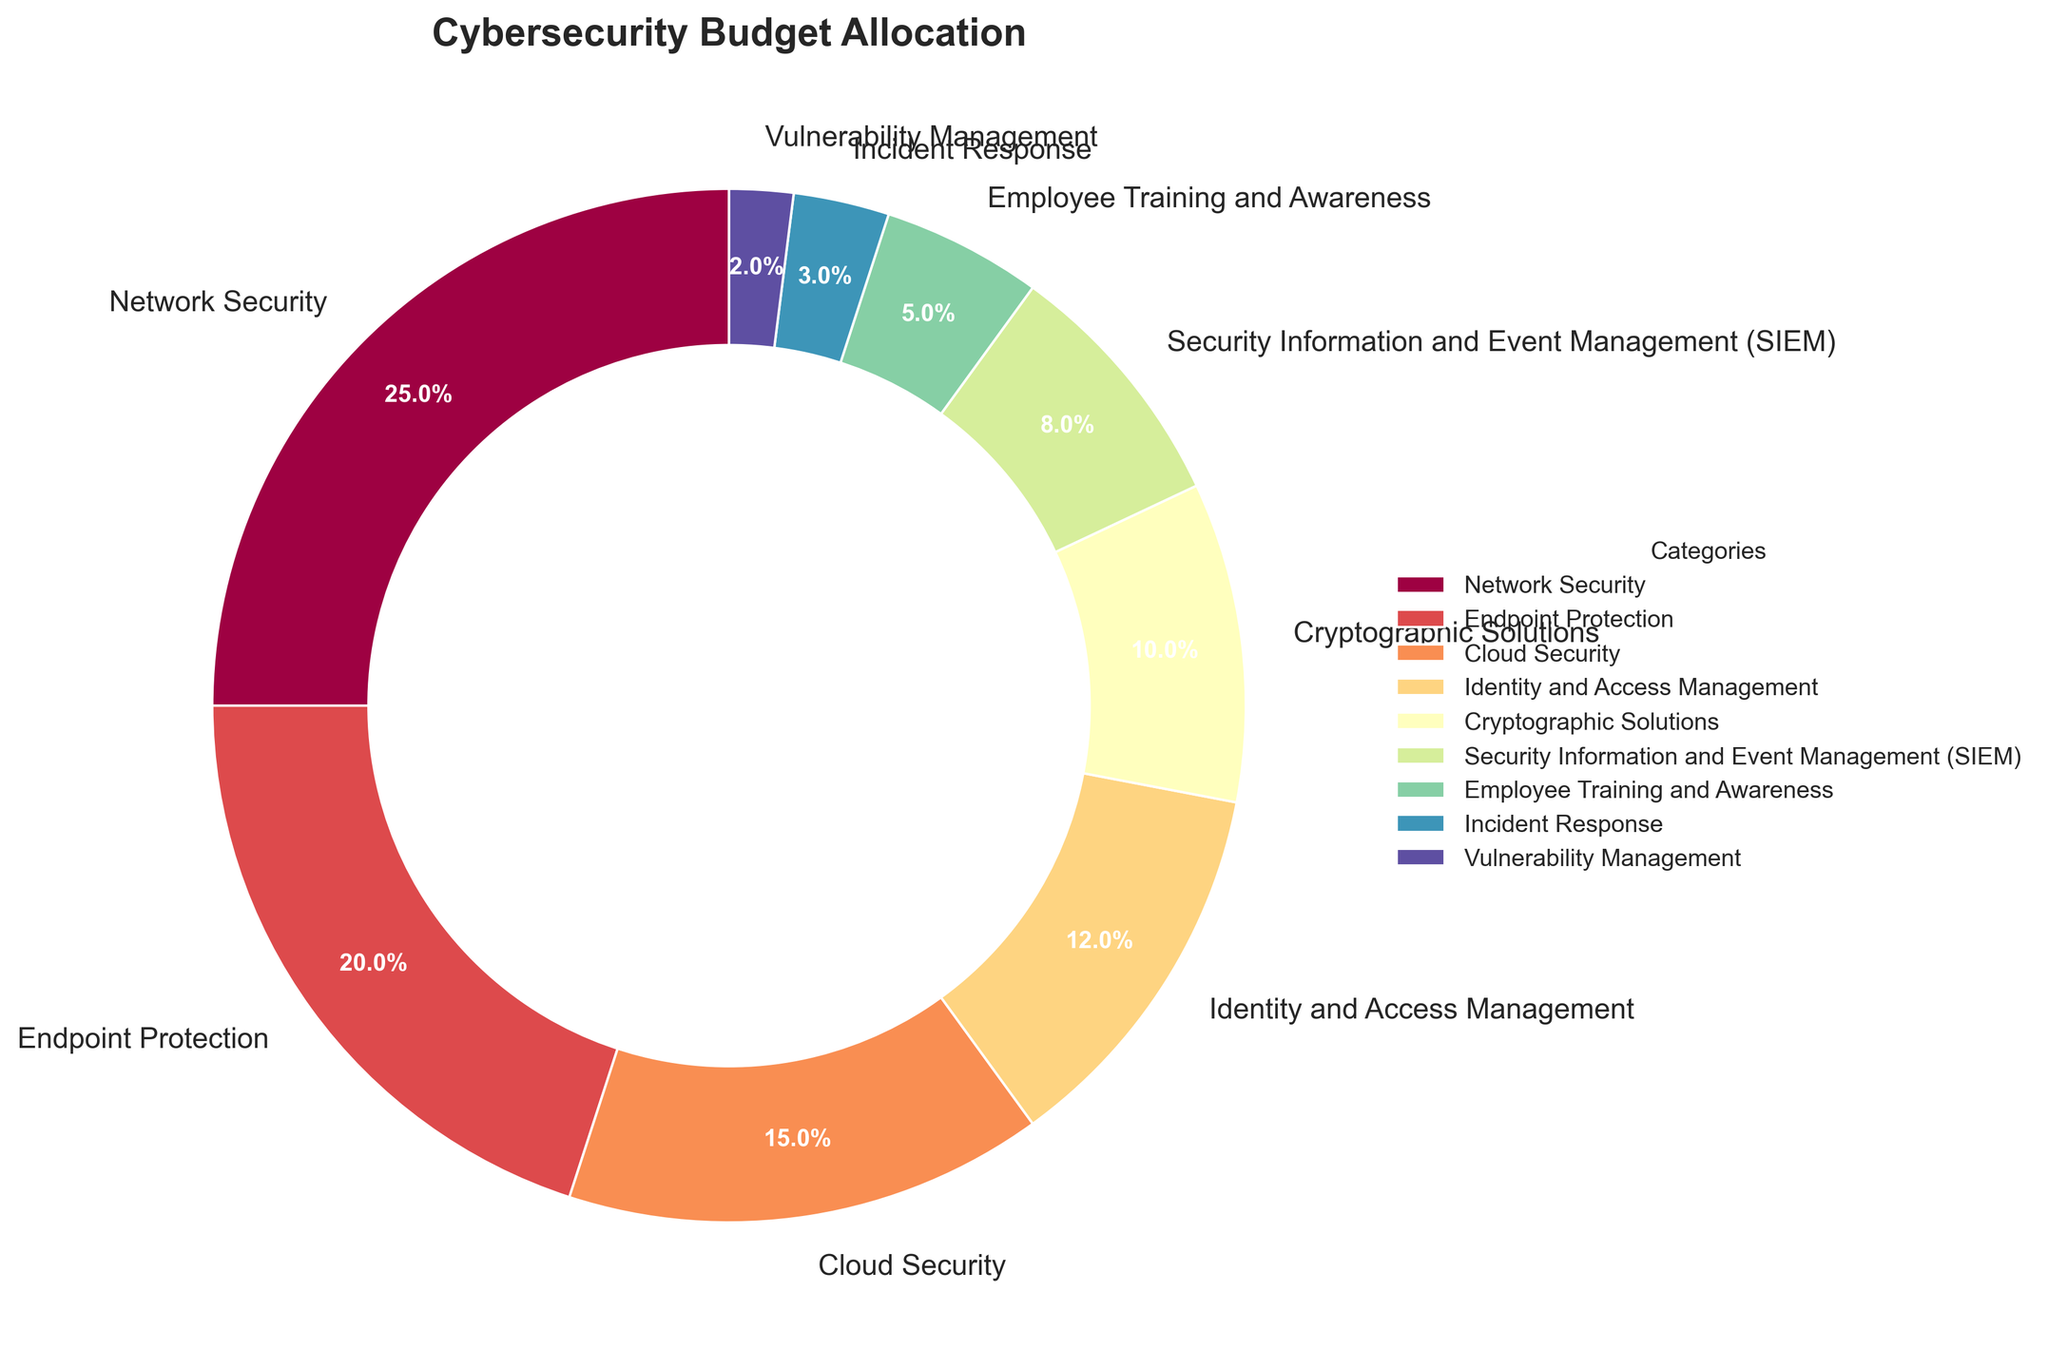What percentage of the budget is allocated to Cryptographic Solutions? Locate the section labeled "Cryptographic Solutions" in the pie chart. It shows 10%, meaning that 10% of the total cybersecurity budget is allocated to cryptographic solutions.
Answer: 10% Which category receives the highest percentage of the budget? Check the segment with the largest slice in the pie chart. Network Security shows the largest slice at 25%.
Answer: Network Security What is the total percentage allocated to Endpoint Protection and Cloud Security combined? Locate the percentages for Endpoint Protection (20%) and Cloud Security (15%). Add these values: 20% + 15% = 35%.
Answer: 35% Is more budget allocated to Identity and Access Management or Employee Training and Awareness? Compare the segments for Identity and Access Management (12%) and Employee Training and Awareness (5%). 12% is larger than 5%.
Answer: Identity and Access Management What is the difference between the budgets allocated to Network Security and Incident Response? Locate the percentages for Network Security (25%) and Incident Response (3%). Subtract the smaller percentage from the larger one: 25% - 3% = 22%.
Answer: 22% Which categories have a budget allocation equal to or less than 10%? Identify segments with 10% or lower. These are Cryptographic Solutions (10%), Security Information and Event Management (8%), Employee Training and Awareness (5%), Incident Response (3%), and Vulnerability Management (2%).
Answer: Cryptographic Solutions, SIEM, Employee Training and Awareness, Incident Response, Vulnerability Management What is the average percentage allocation for the following categories: Cloud Security, Identity and Access Management, and SIEM? Locate the percentages for Cloud Security (15%), Identity and Access Management (12%), and SIEM (8%). Add these values: 15% + 12% + 8% = 35%. Divide by the number of categories: 35% / 3 ≈ 11.67%.
Answer: 11.67% How does the budget allocation for Cryptographic Solutions compare to Network Security in terms of percentage? Compare the percentages of Cryptographic Solutions (10%) and Network Security (25%). Cryptographic Solutions has a smaller allocation by 15 percentage points.
Answer: Network Security has 15% more What percentage of the budget is allocated to categories other than Network Security, Endpoint Protection, and Cloud Security? Add the percentages for Network Security (25%), Endpoint Protection (20%), and Cloud Security (15%): 25% + 20% + 15% = 60%. Subtract this from 100%: 100% - 60% = 40%.
Answer: 40% In terms of percentage, how much more is allocated to Endpoint Protection than to SIEM? Locate the percentages for Endpoint Protection (20%) and SIEM (8%). Subtract the smaller value from the larger one: 20% - 8% = 12%.
Answer: 12% 